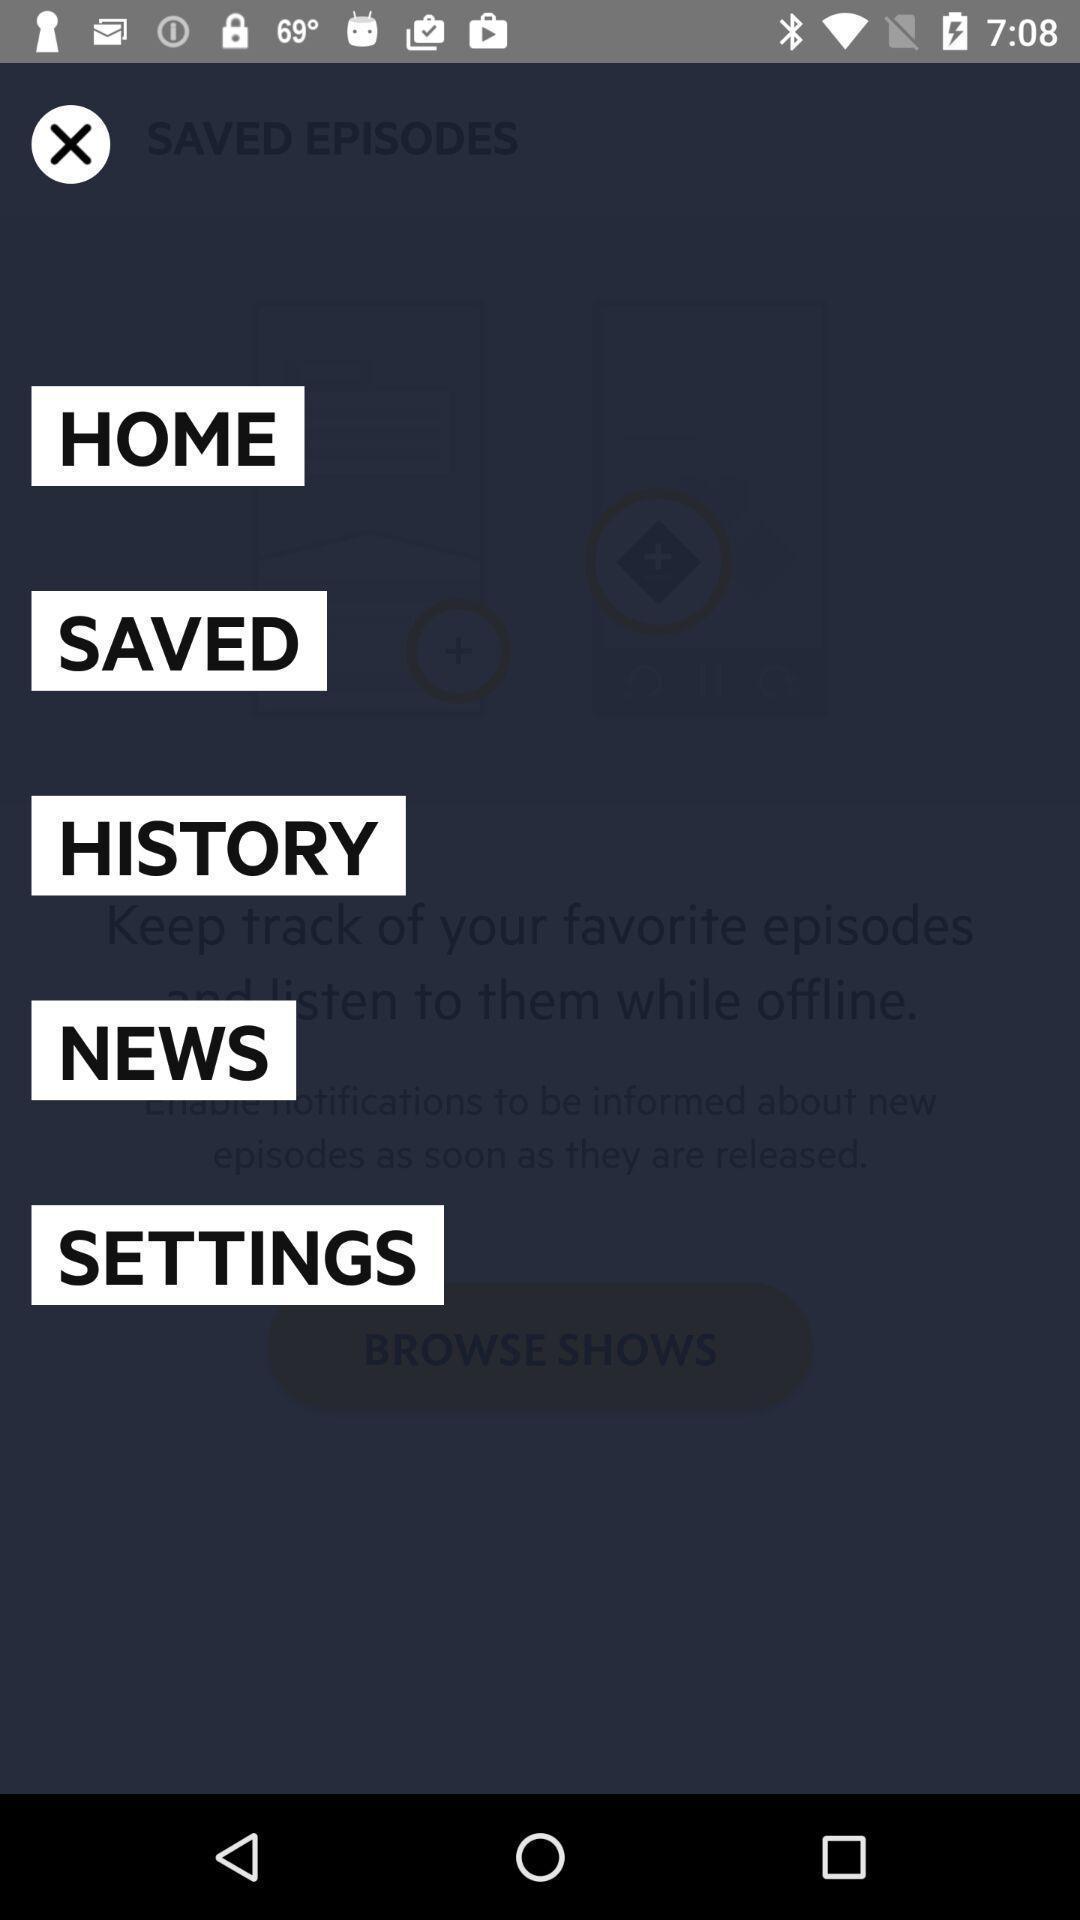Explain what's happening in this screen capture. Popup displaying information about a live streaming application. 